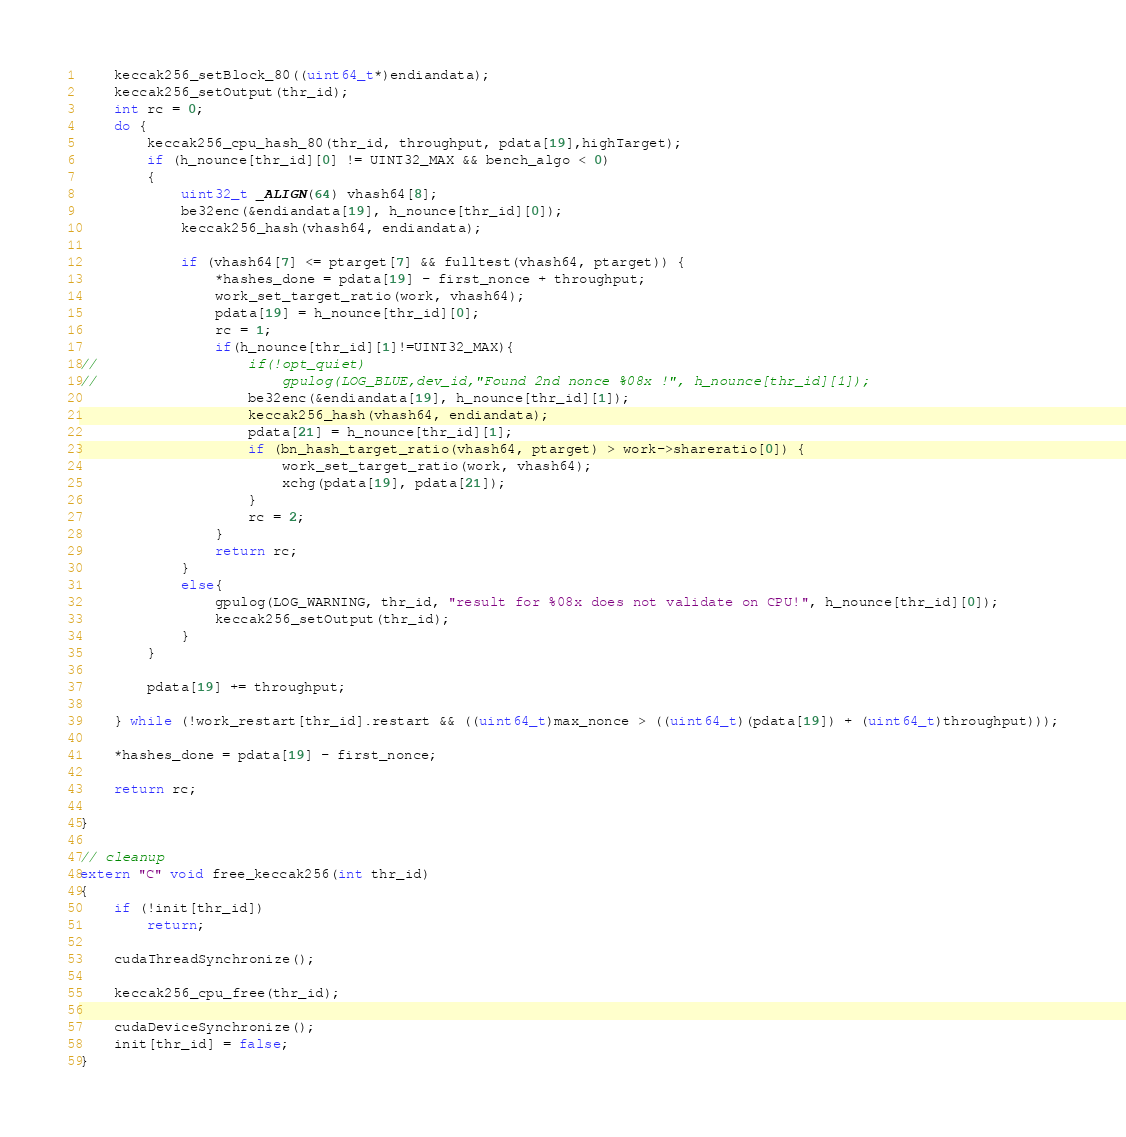Convert code to text. <code><loc_0><loc_0><loc_500><loc_500><_Cuda_>	keccak256_setBlock_80((uint64_t*)endiandata);
	keccak256_setOutput(thr_id);
	int rc = 0;
	do {
		keccak256_cpu_hash_80(thr_id, throughput, pdata[19],highTarget);
		if (h_nounce[thr_id][0] != UINT32_MAX && bench_algo < 0)
		{
			uint32_t _ALIGN(64) vhash64[8];
			be32enc(&endiandata[19], h_nounce[thr_id][0]);
			keccak256_hash(vhash64, endiandata);

			if (vhash64[7] <= ptarget[7] && fulltest(vhash64, ptarget)) {
				*hashes_done = pdata[19] - first_nonce + throughput;
				work_set_target_ratio(work, vhash64);
				pdata[19] = h_nounce[thr_id][0];
				rc = 1;
				if(h_nounce[thr_id][1]!=UINT32_MAX){
//					if(!opt_quiet)
//						gpulog(LOG_BLUE,dev_id,"Found 2nd nonce %08x !", h_nounce[thr_id][1]);
					be32enc(&endiandata[19], h_nounce[thr_id][1]);
					keccak256_hash(vhash64, endiandata);
					pdata[21] = h_nounce[thr_id][1];
					if (bn_hash_target_ratio(vhash64, ptarget) > work->shareratio[0]) {
						work_set_target_ratio(work, vhash64);
						xchg(pdata[19], pdata[21]);
					}
					rc = 2;
				}
				return rc;
			}
			else{
				gpulog(LOG_WARNING, thr_id, "result for %08x does not validate on CPU!", h_nounce[thr_id][0]);
				keccak256_setOutput(thr_id);
			}
		}

		pdata[19] += throughput;

	} while (!work_restart[thr_id].restart && ((uint64_t)max_nonce > ((uint64_t)(pdata[19]) + (uint64_t)throughput)));

	*hashes_done = pdata[19] - first_nonce;

	return rc;

}

// cleanup
extern "C" void free_keccak256(int thr_id)
{
	if (!init[thr_id])
		return;

	cudaThreadSynchronize();

	keccak256_cpu_free(thr_id);

	cudaDeviceSynchronize();
	init[thr_id] = false;
}
</code> 